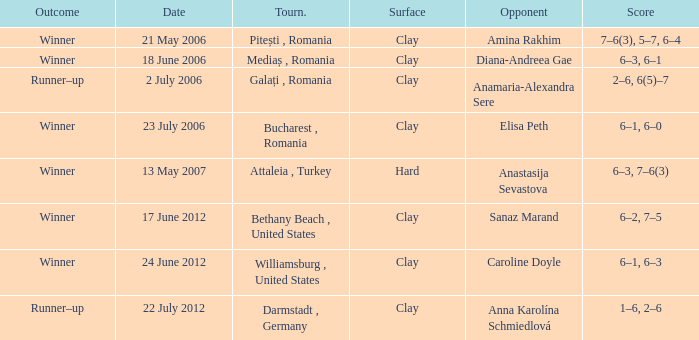What was the score in the match against Sanaz Marand? 6–2, 7–5. 